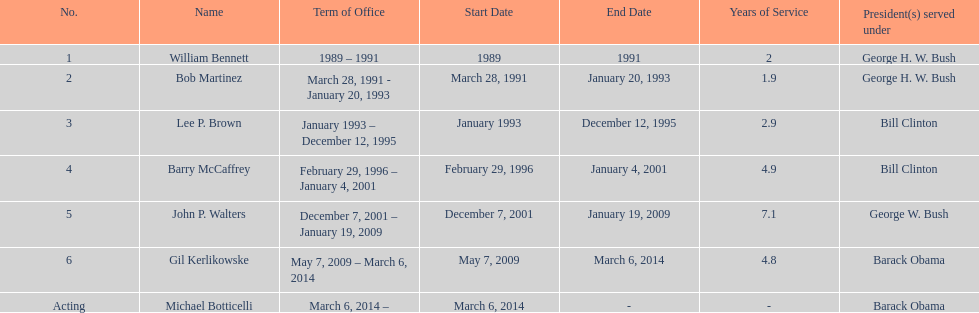How long did bob martinez serve as director? 2 years. 